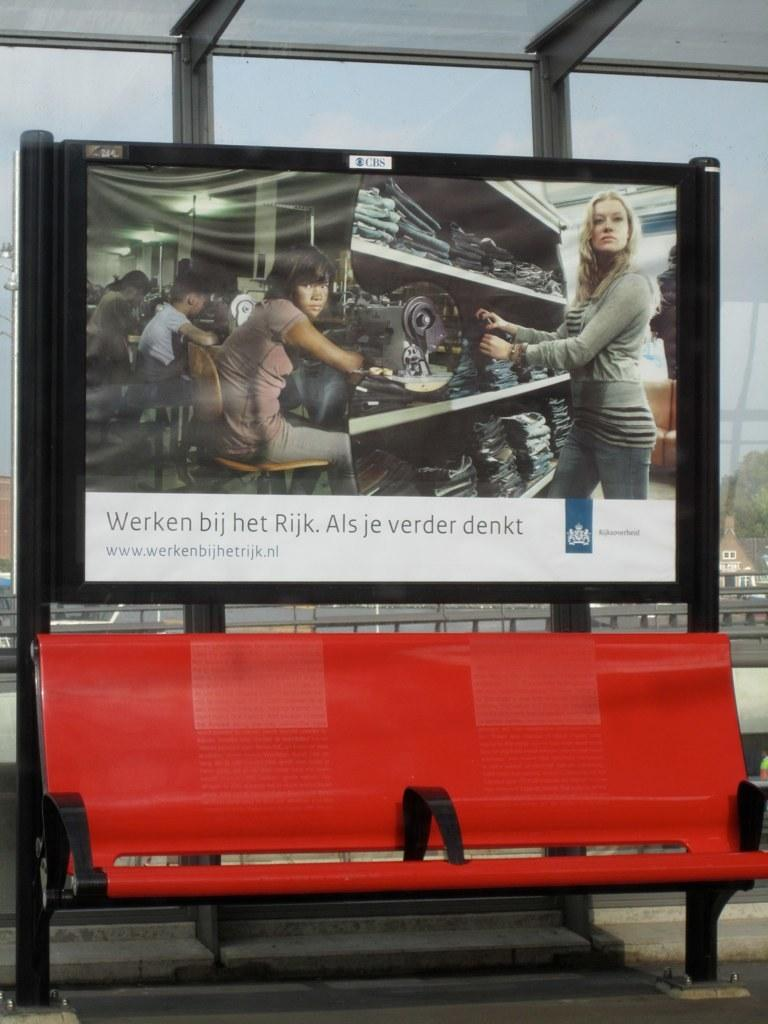What type of seating is present in the image? There is a bench in the image. What can be seen on a stand in the image? There is a poster on a stand in the image. What type of material is used for the windows in the image? There are glass windows visible in the image. How many sticks are used to hold up the poster in the image? There is no mention of sticks being used to hold up the poster in the image. The poster is simply on a stand. What type of railway is visible in the image? There is no railway present in the image. The image features a bench, a poster on a stand, and glass windows. 